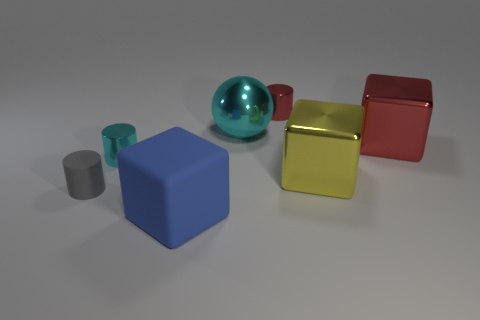There is a thing that is the same color as the big shiny ball; what is its shape?
Provide a short and direct response. Cylinder. Is there a tiny matte object that has the same shape as the big cyan metal thing?
Provide a short and direct response. No. What is the color of the big thing that is behind the red shiny thing on the right side of the small red metal cylinder?
Offer a terse response. Cyan. Is the number of green shiny blocks greater than the number of tiny red cylinders?
Offer a terse response. No. What number of blue metal spheres have the same size as the red metal cylinder?
Ensure brevity in your answer.  0. Are the big red block and the large cube that is to the left of the small red metallic thing made of the same material?
Keep it short and to the point. No. Are there fewer rubber blocks than big purple rubber blocks?
Your answer should be compact. No. Is there anything else of the same color as the rubber cube?
Ensure brevity in your answer.  No. What shape is the small red object that is the same material as the big yellow block?
Your answer should be very brief. Cylinder. There is a large yellow object that is in front of the cyan object behind the small cyan shiny object; how many blue things are behind it?
Offer a terse response. 0. 